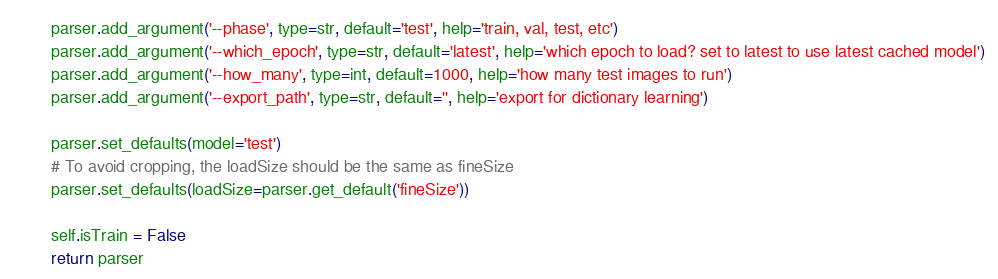<code> <loc_0><loc_0><loc_500><loc_500><_Python_>        parser.add_argument('--phase', type=str, default='test', help='train, val, test, etc')
        parser.add_argument('--which_epoch', type=str, default='latest', help='which epoch to load? set to latest to use latest cached model')
        parser.add_argument('--how_many', type=int, default=1000, help='how many test images to run')
        parser.add_argument('--export_path', type=str, default='', help='export for dictionary learning')

        parser.set_defaults(model='test')
        # To avoid cropping, the loadSize should be the same as fineSize
        parser.set_defaults(loadSize=parser.get_default('fineSize'))

        self.isTrain = False
        return parser
</code> 